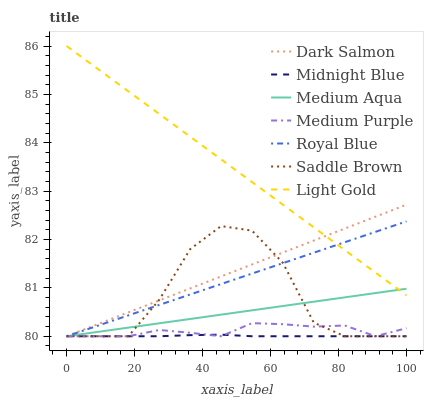Does Midnight Blue have the minimum area under the curve?
Answer yes or no. Yes. Does Light Gold have the maximum area under the curve?
Answer yes or no. Yes. Does Dark Salmon have the minimum area under the curve?
Answer yes or no. No. Does Dark Salmon have the maximum area under the curve?
Answer yes or no. No. Is Dark Salmon the smoothest?
Answer yes or no. Yes. Is Saddle Brown the roughest?
Answer yes or no. Yes. Is Medium Purple the smoothest?
Answer yes or no. No. Is Medium Purple the roughest?
Answer yes or no. No. Does Midnight Blue have the lowest value?
Answer yes or no. Yes. Does Light Gold have the lowest value?
Answer yes or no. No. Does Light Gold have the highest value?
Answer yes or no. Yes. Does Dark Salmon have the highest value?
Answer yes or no. No. Is Medium Purple less than Light Gold?
Answer yes or no. Yes. Is Light Gold greater than Medium Purple?
Answer yes or no. Yes. Does Midnight Blue intersect Saddle Brown?
Answer yes or no. Yes. Is Midnight Blue less than Saddle Brown?
Answer yes or no. No. Is Midnight Blue greater than Saddle Brown?
Answer yes or no. No. Does Medium Purple intersect Light Gold?
Answer yes or no. No. 